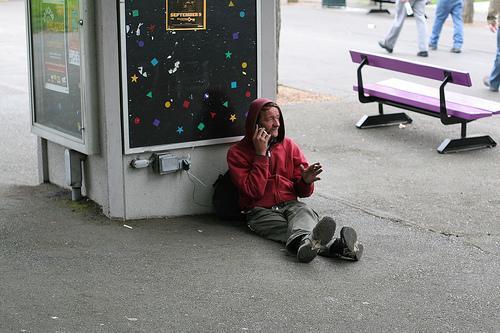How many people are in the picture?
Give a very brief answer. 1. 